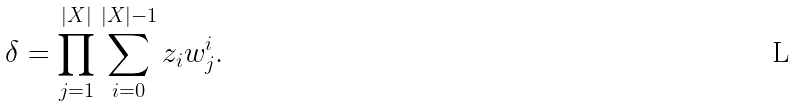Convert formula to latex. <formula><loc_0><loc_0><loc_500><loc_500>\delta = \prod ^ { | X | } _ { j = 1 } \sum _ { i = 0 } ^ { | X | - 1 } z _ { i } w ^ { i } _ { j } .</formula> 